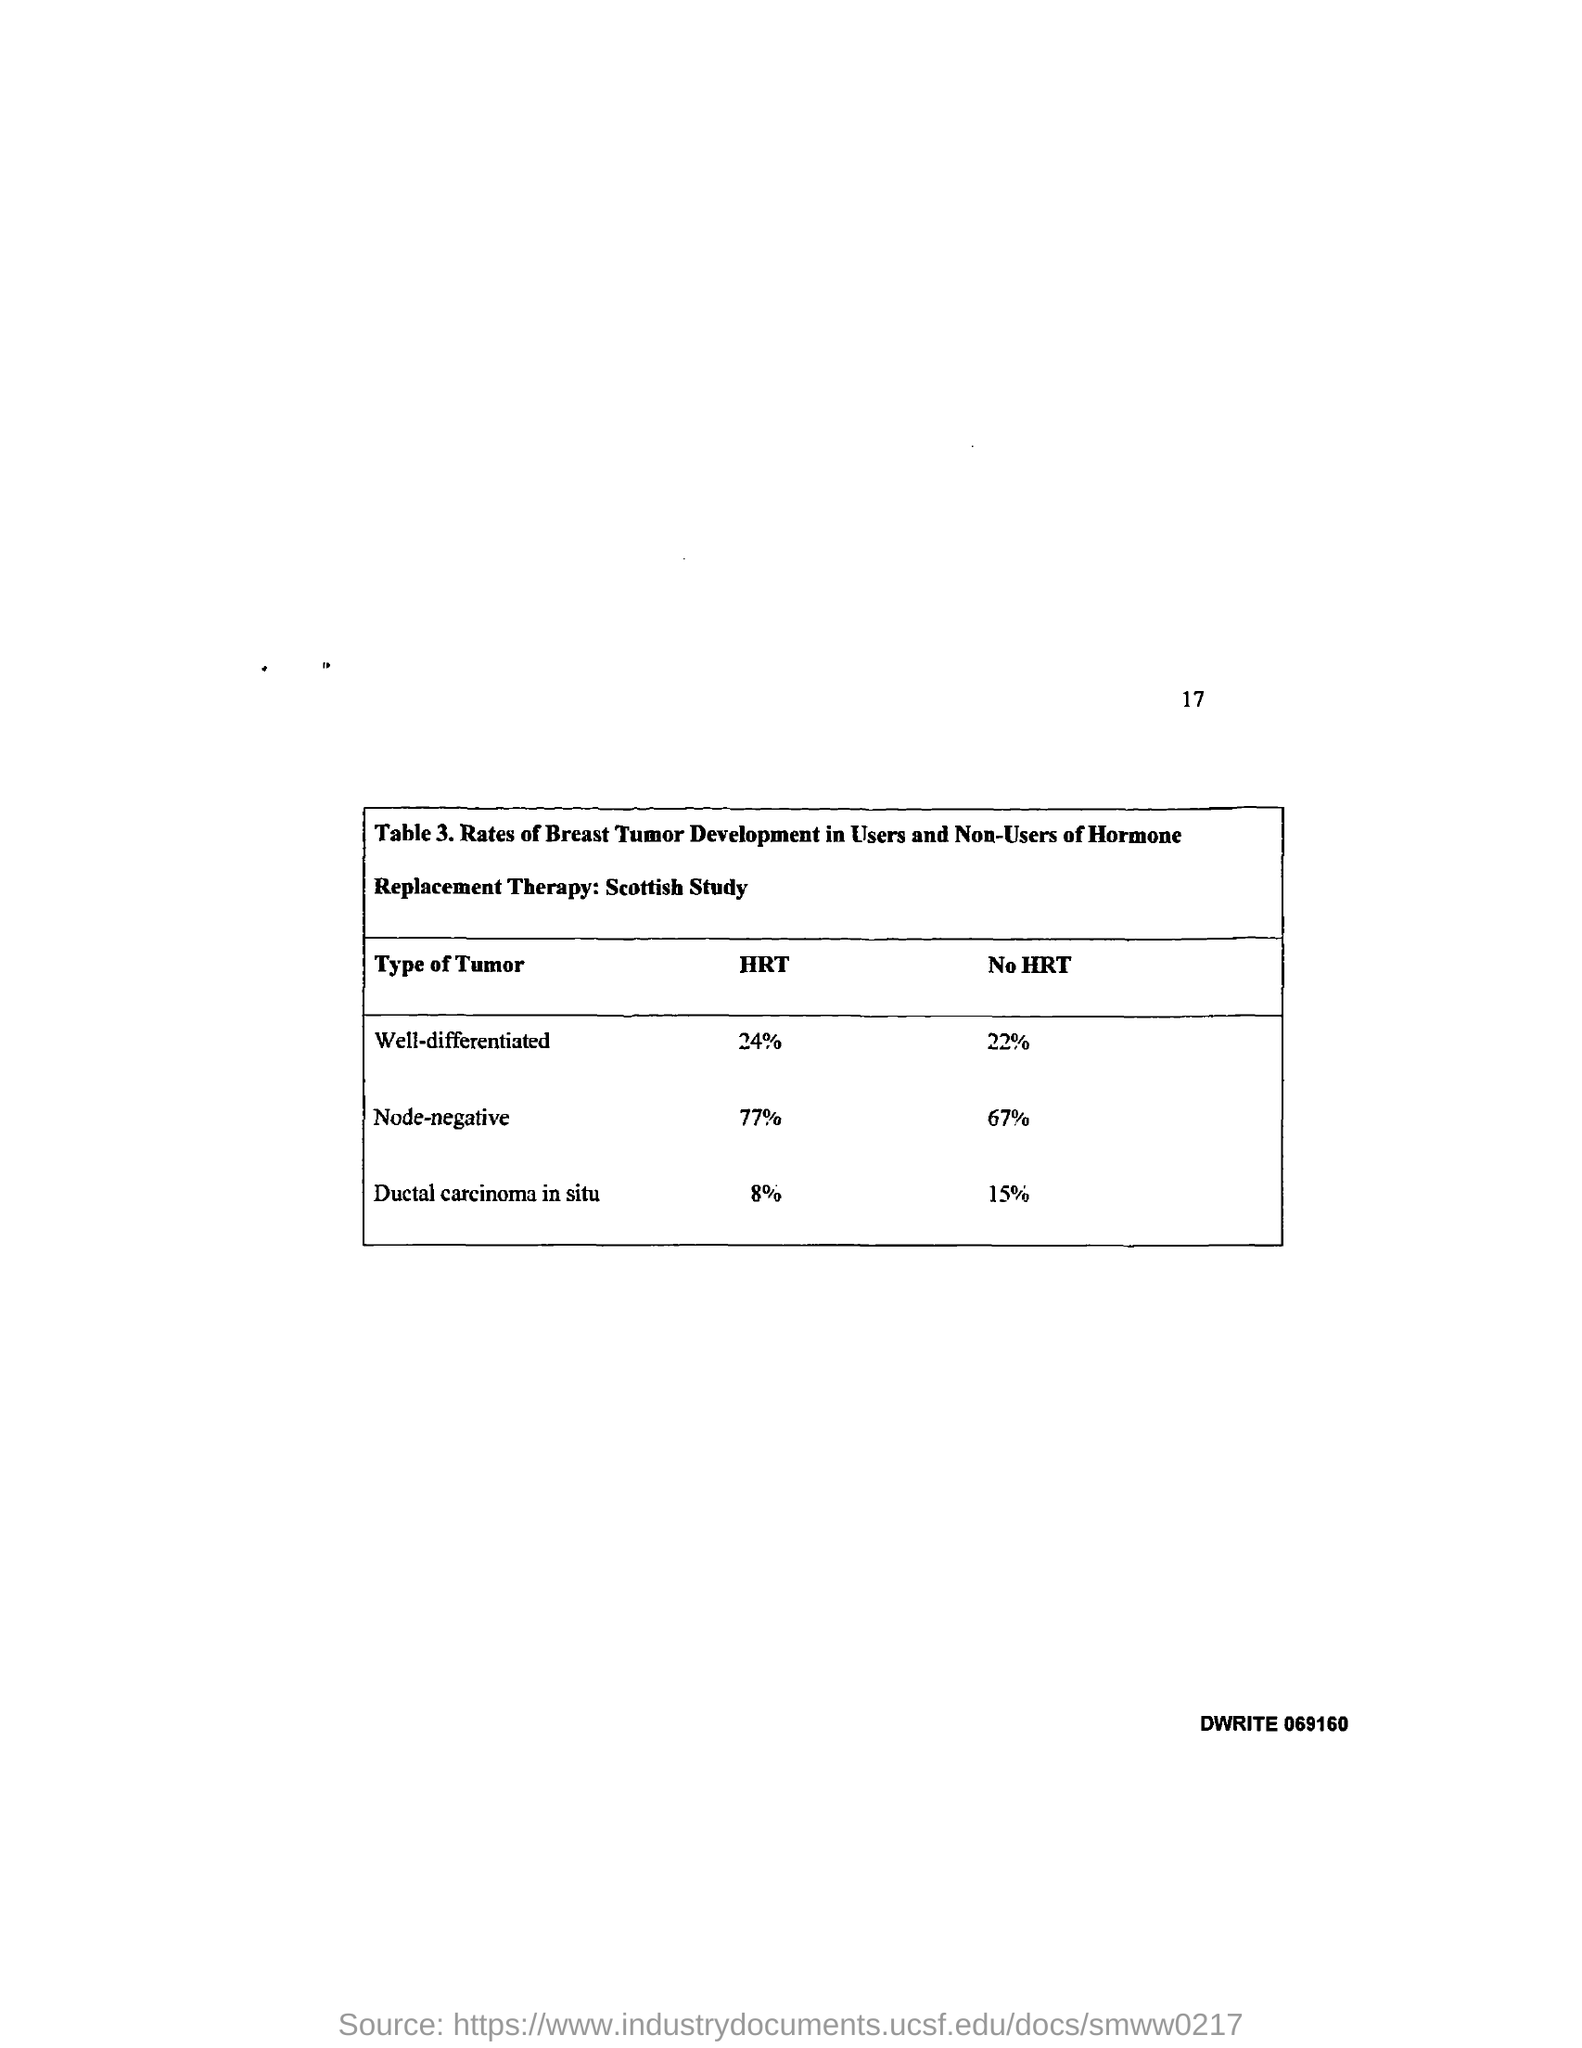What is the page no mentioned in this document?
Offer a very short reply. 17. What type of tumor is developed in users with 24% HRT?
Offer a very short reply. WELL- DIFFERENTIATED. What type of tumor is developed in users with 77% HRT?
Keep it short and to the point. Node-negative. 